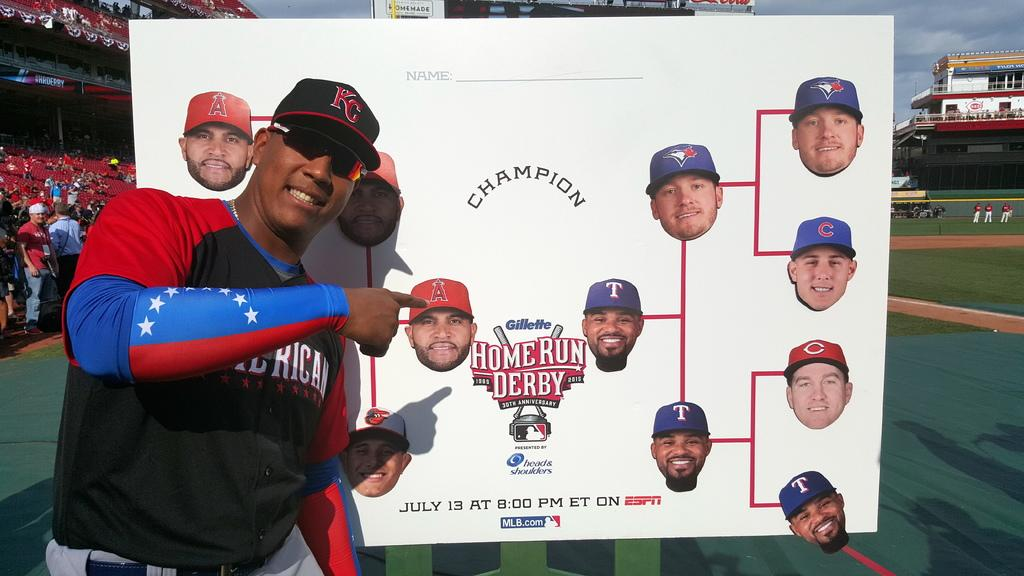<image>
Present a compact description of the photo's key features. A baseball player is posing in front of a Home Run Derby poster 